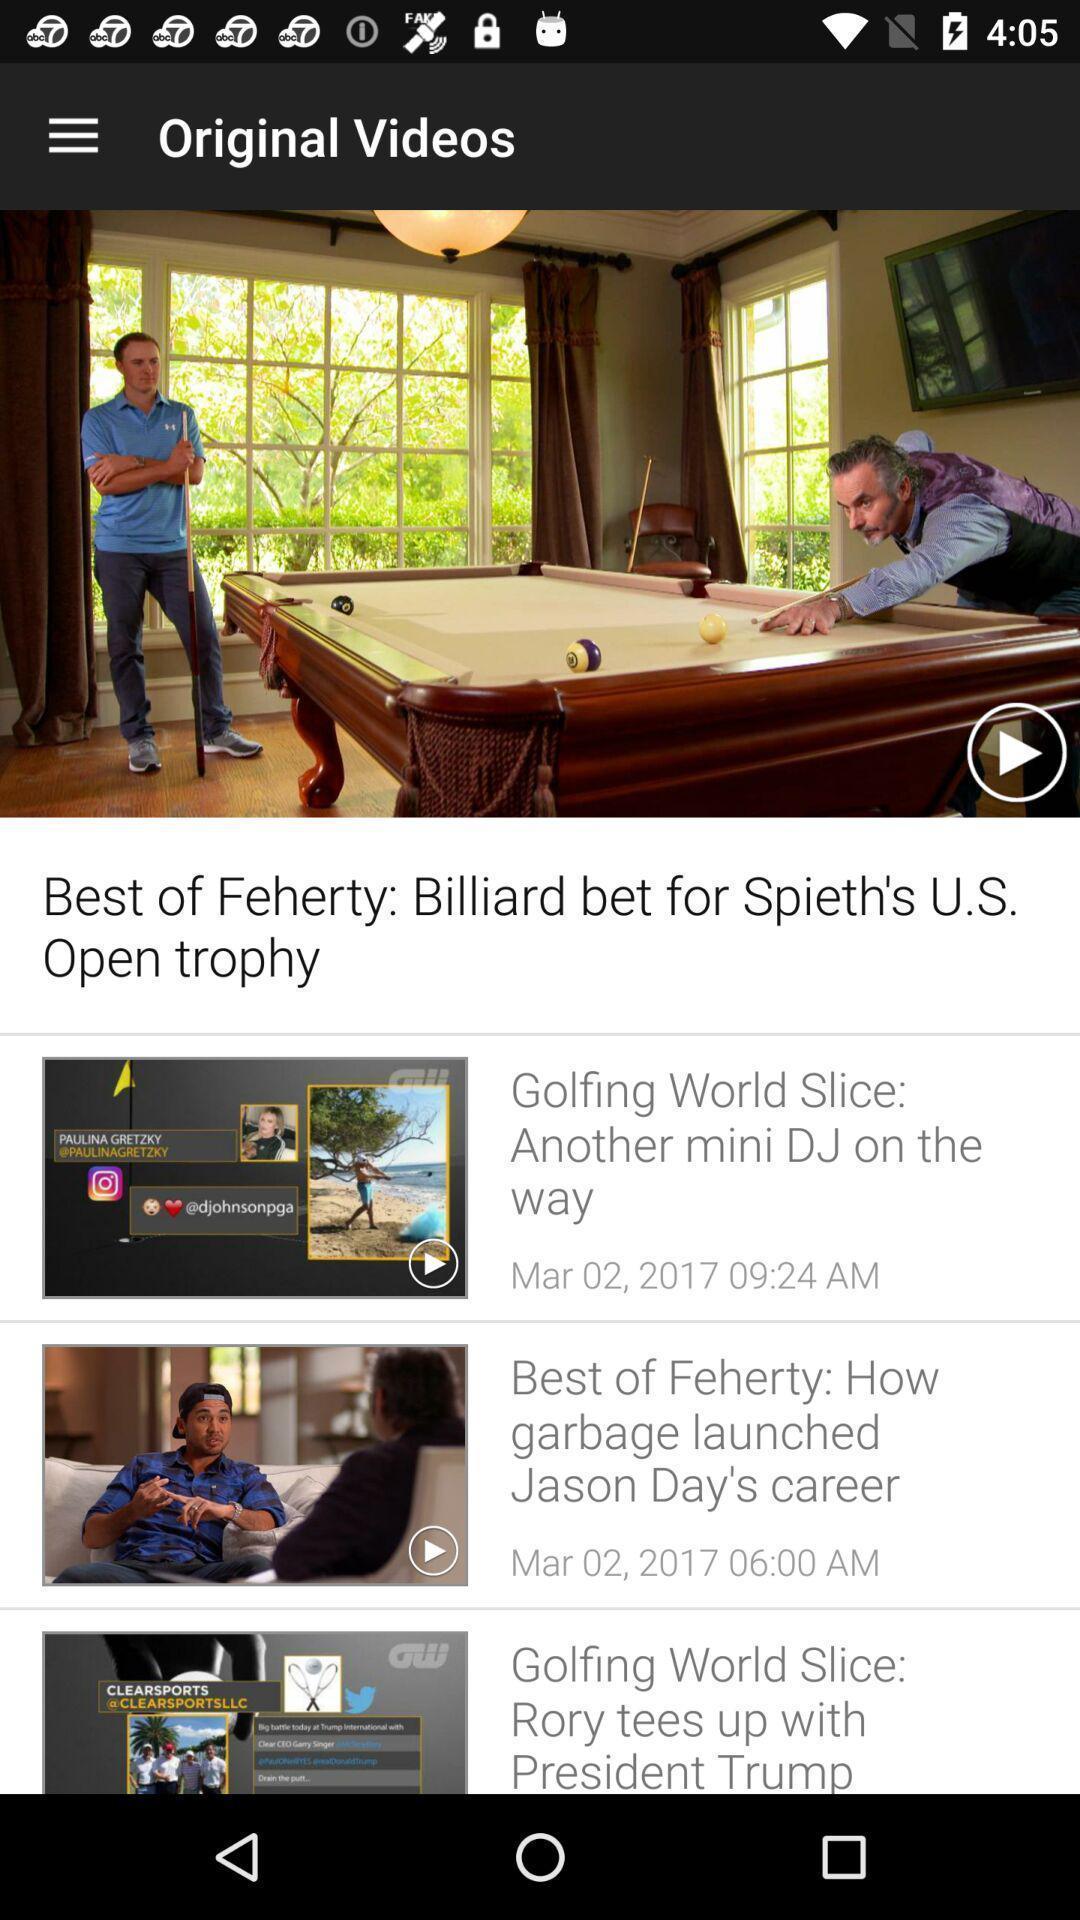What can you discern from this picture? Screen displaying multiple videos with names. 